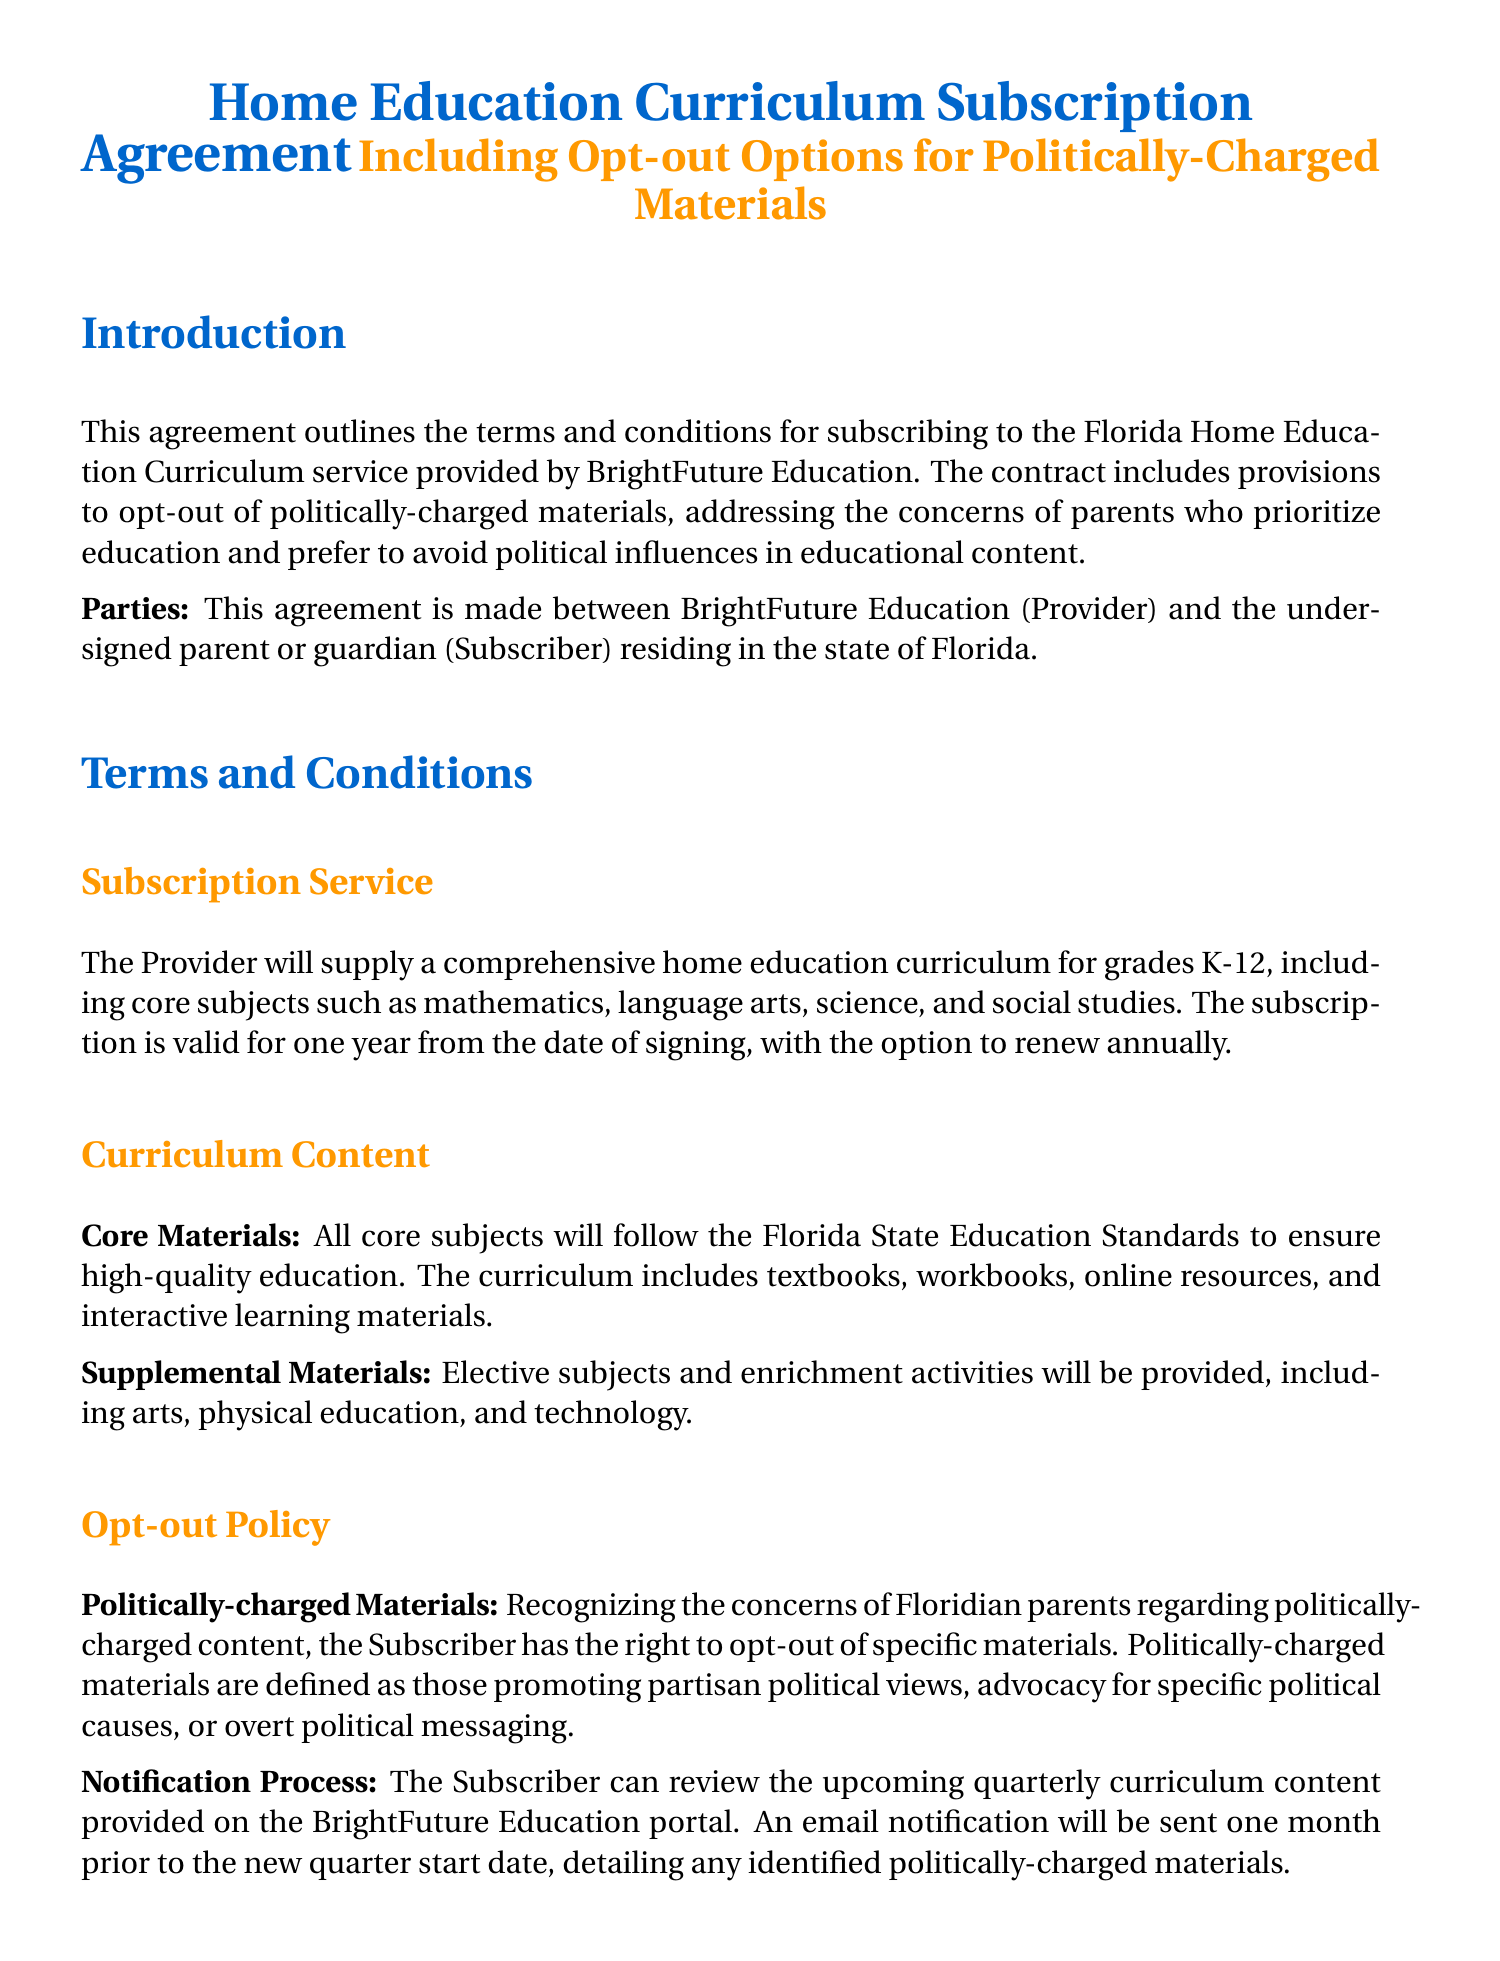What is the annual subscription fee? The document states that the annual subscription fee is specific and clearly mentioned in the payment section.
Answer: $1,200 How long is the subscription valid? The document specifies the duration of the subscription in the Subscription Service section.
Answer: One year What is the process to opt-out of politically-charged materials? The document outlines the steps that need to be followed to opt-out in the Opt-out Procedure section.
Answer: Submit the Opt-out Request Form What materials are included in the curriculum? The document references the types of materials provided in the Curriculum Content section.
Answer: Textbooks, workbooks, online resources, and interactive learning materials What happens if the Subscriber is not satisfied within the first 30 days? The options for a Subscriber dissatisfied with the service during the initial period are outlined in the Fees and Payment section.
Answer: Full refund What happens if either party wants to terminate the agreement? The document describes the termination conditions in the Termination Clause section, detailing the notice required and refund policy.
Answer: Written notice What is the notification timeframe for politically-charged materials? The timeframe for the notification process regarding politically-charged materials is mentioned in the Notification Process section.
Answer: One month Who is the Provider in this agreement? The document explicitly identifies the parties involved at the beginning of the agreement.
Answer: BrightFuture Education 